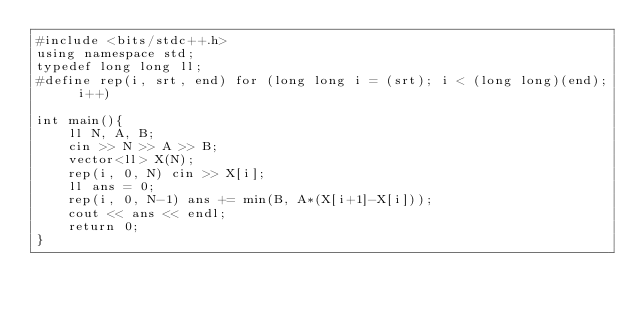Convert code to text. <code><loc_0><loc_0><loc_500><loc_500><_C++_>#include <bits/stdc++.h>
using namespace std;
typedef long long ll;
#define rep(i, srt, end) for (long long i = (srt); i < (long long)(end); i++)

int main(){
    ll N, A, B;
    cin >> N >> A >> B;
    vector<ll> X(N);
    rep(i, 0, N) cin >> X[i];
    ll ans = 0;
    rep(i, 0, N-1) ans += min(B, A*(X[i+1]-X[i]));
    cout << ans << endl;
    return 0;
}</code> 